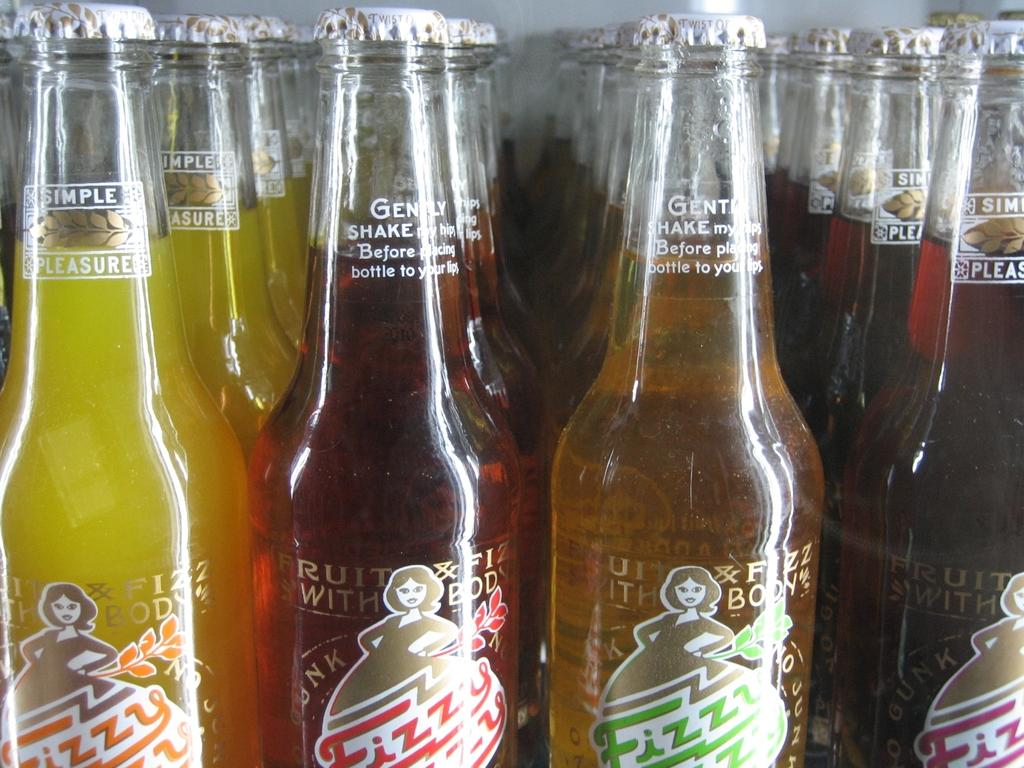<image>
Share a concise interpretation of the image provided. A collection of Fizzy drinks that instruct you to gently shake before placing the bottle to your lips. 